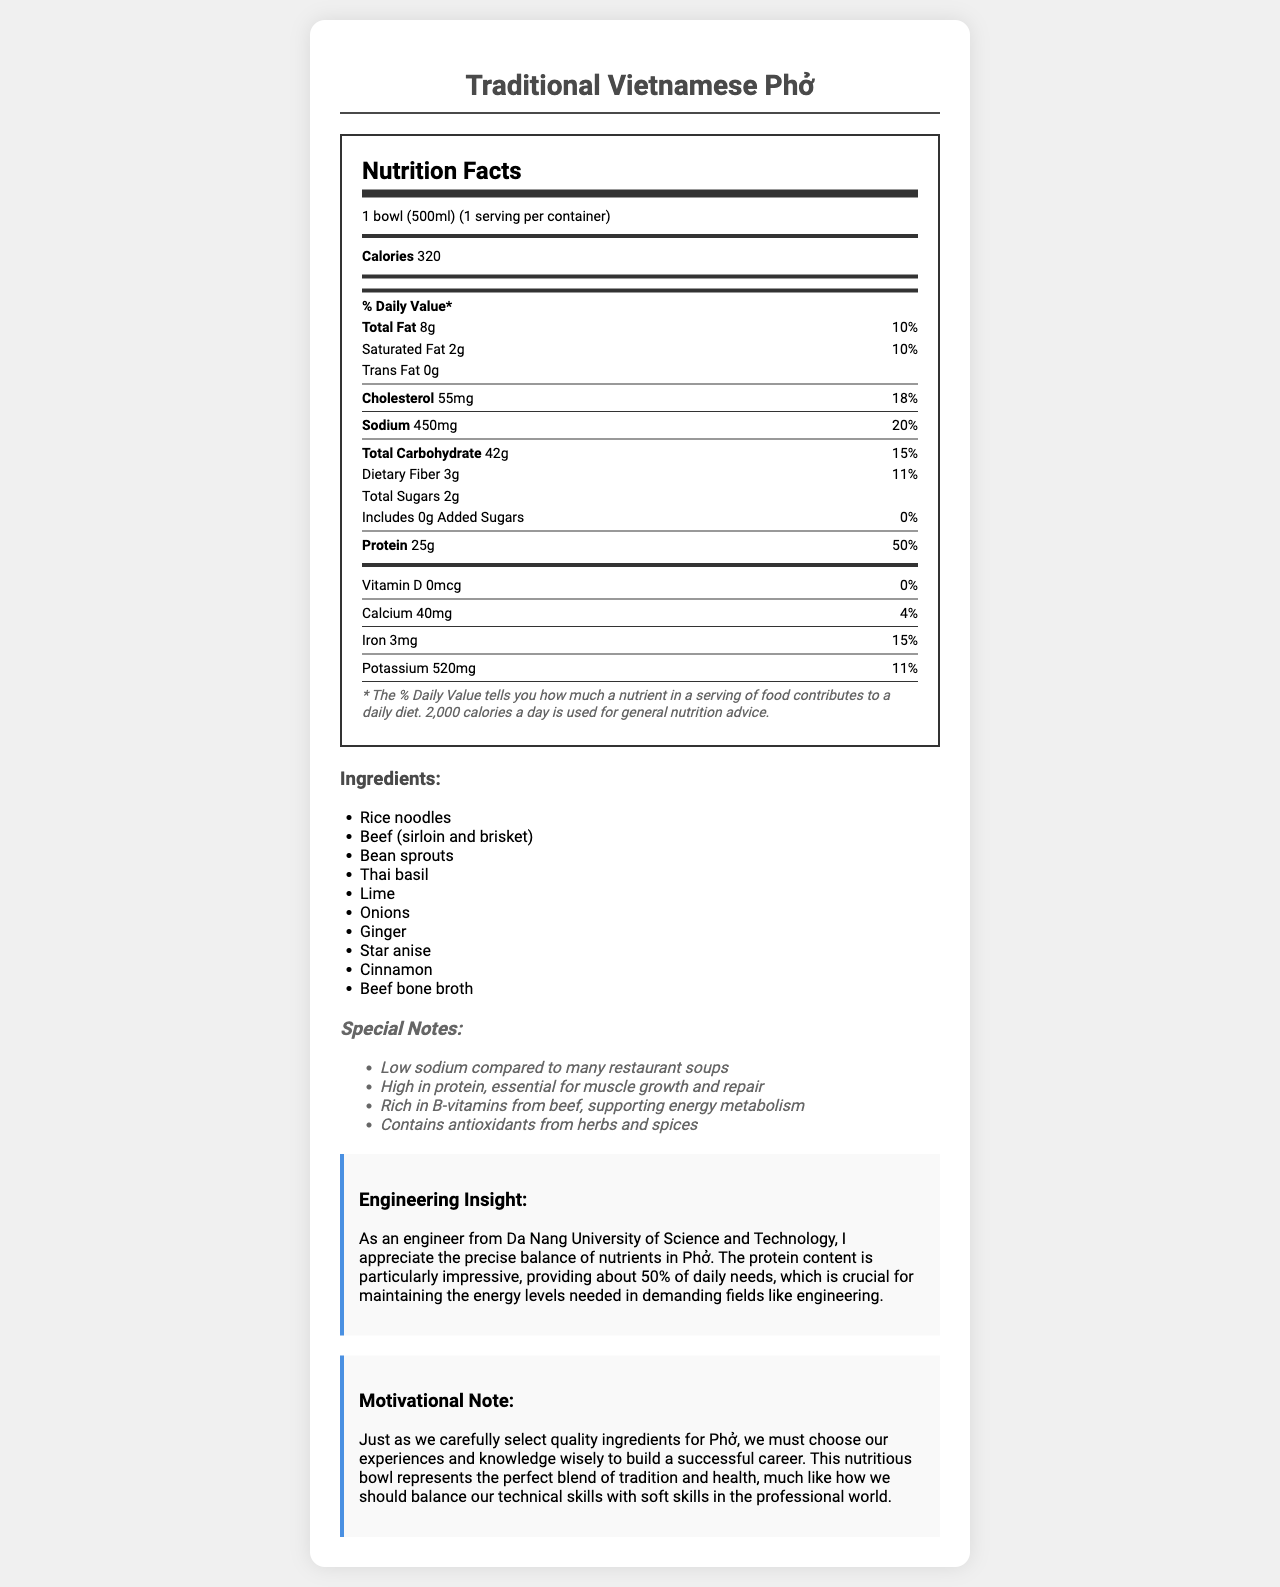What is the serving size for the Traditional Vietnamese Phở? The serving size is listed as "1 bowl (500ml)" under the Nutrition Facts section.
Answer: 1 bowl (500ml) How many calories are in one serving of Traditional Vietnamese Phở? The document states that there are 320 calories per serving.
Answer: 320 What percentage of the daily value for protein does the Phở provide? The protein content is 25g, which is marked as 50% of the daily value.
Answer: 50% List three main ingredients found in the Phở. These ingredients are found in the ingredients list.
Answer: Rice noodles, Beef (sirloin and brisket), Bean sprouts How much sodium is in one serving of the Phở? The sodium content is listed as 450 mg in the Nutrition Facts section.
Answer: 450 mg What is the daily value percentage for calcium in the Phở? The document indicates that the calcium content is 40mg with a daily value of 4%.
Answer: 4% What are the health benefits mentioned for consuming this Phở? These benefits are noted under the Special Notes section.
Answer: High in protein, Rich in B-vitamins, Contains antioxidants Is this Phở high in sodium compared to many restaurant soups? The document mentions that it's low in sodium compared to many restaurant soups.
Answer: No Which nutrient contributes the most to the daily value in this Phở? A. Protein B. Calcium C. Dietary Fiber D. Sodium The protein content contributes 50% to the daily value, which is the highest among the listed nutrients.
Answer: A. Protein How many grams of dietary fiber are in one serving of Phở? A. 1 gram B. 2 grams C. 3 grams D. 4 grams The dietary fiber content is listed as 3 grams in the Nutrition Facts section.
Answer: C. 3 grams Does the Phở contain added sugars? The label indicates that there are 0 grams of added sugars.
Answer: No Describe the main idea of this document. This is a summary of the entire document, which covers various aspects such as nutritional facts, ingredients, and special notes about the product's benefits.
Answer: The document provides detailed nutritional information about a serving of Traditional Vietnamese Phở, emphasizing its high protein content and relatively low sodium levels compared to other soups. It also lists ingredients, potential allergens, and special health benefits. Does the Phở contain any common allergens? If yes, which ones? The document mentions that the Phở may contain soy under the allergens section.
Answer: May contain soy How does the Phở support energy metabolism according to the document? The special notes section highlights that the Phở is rich in B-vitamins from beef, which supports energy metabolism.
Answer: Rich in B-vitamins from beef Where is the nutritional information about this Phở from? The document does not provide information about the source of the nutritional data.
Answer: Not enough information 